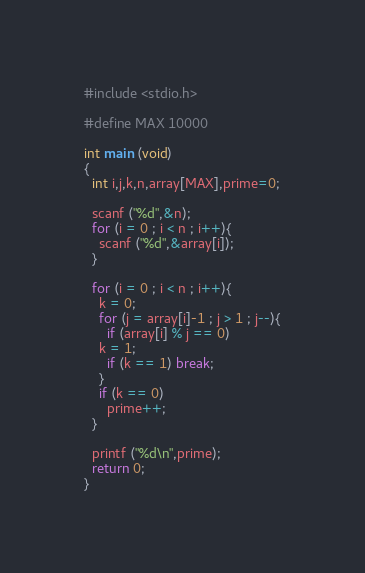<code> <loc_0><loc_0><loc_500><loc_500><_C_>#include <stdio.h>

#define MAX 10000

int main (void)
{
  int i,j,k,n,array[MAX],prime=0;

  scanf ("%d",&n);
  for (i = 0 ; i < n ; i++){
    scanf ("%d",&array[i]);
  }

  for (i = 0 ; i < n ; i++){
    k = 0;
    for (j = array[i]-1 ; j > 1 ; j--){
      if (array[i] % j == 0)
	k = 1;
      if (k == 1) break;
    }
    if (k == 0)
      prime++;
  }

  printf ("%d\n",prime);
  return 0;
}</code> 